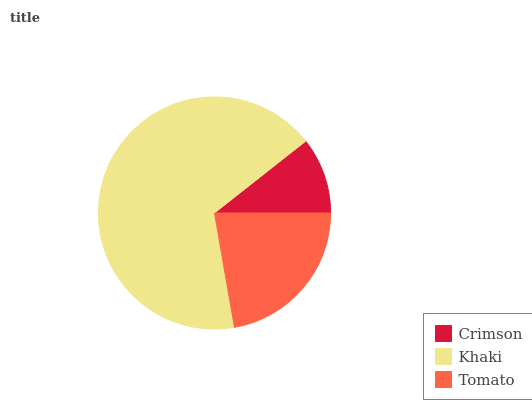Is Crimson the minimum?
Answer yes or no. Yes. Is Khaki the maximum?
Answer yes or no. Yes. Is Tomato the minimum?
Answer yes or no. No. Is Tomato the maximum?
Answer yes or no. No. Is Khaki greater than Tomato?
Answer yes or no. Yes. Is Tomato less than Khaki?
Answer yes or no. Yes. Is Tomato greater than Khaki?
Answer yes or no. No. Is Khaki less than Tomato?
Answer yes or no. No. Is Tomato the high median?
Answer yes or no. Yes. Is Tomato the low median?
Answer yes or no. Yes. Is Khaki the high median?
Answer yes or no. No. Is Crimson the low median?
Answer yes or no. No. 